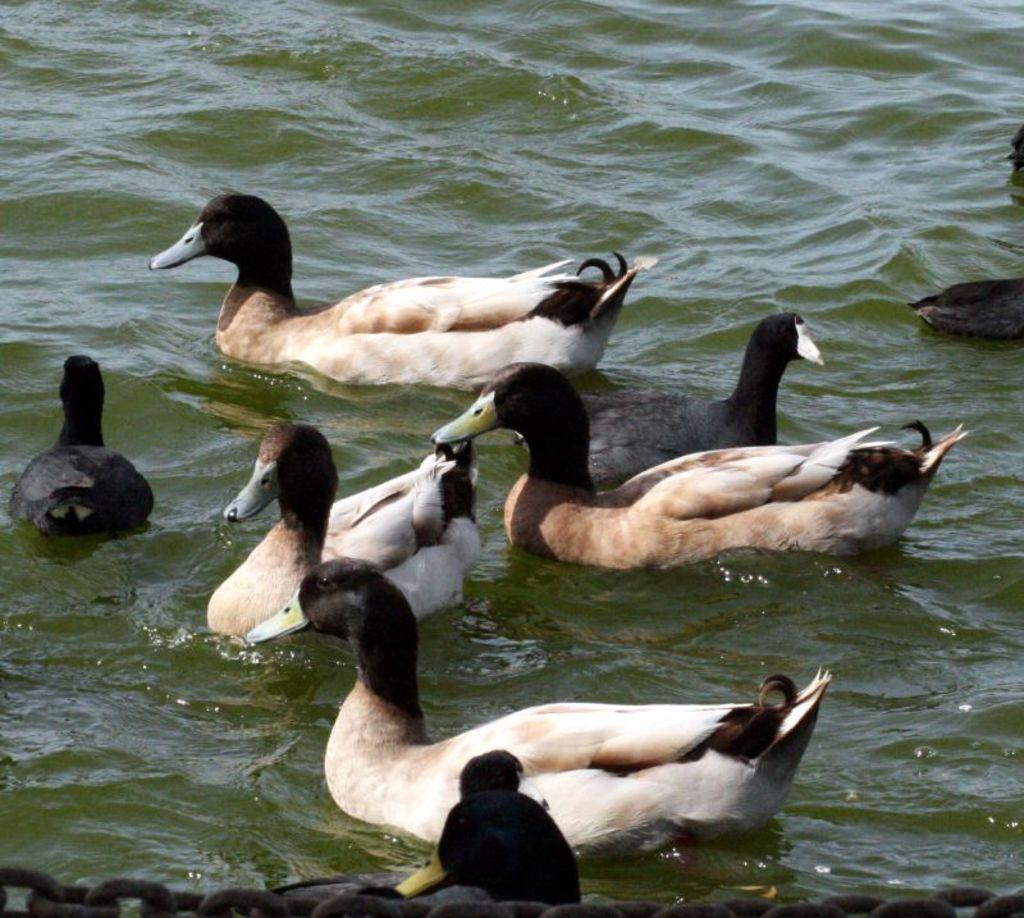How would you summarize this image in a sentence or two? In this picture there are ducks in the center of the image in the water. 